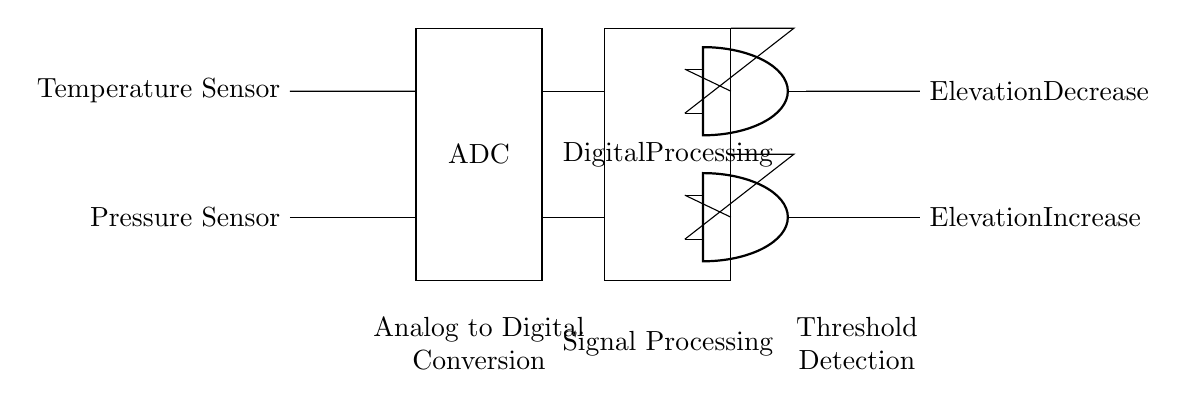What are the input sensors used in this circuit? The circuit shows a pressure sensor and a temperature sensor as inputs. These sensors gather data which will be processed to determine elevation changes.
Answer: Pressure sensor, Temperature sensor What does the ADC stand for in the circuit? In this context, ADC stands for Analog to Digital Converter. It converts the analog signals from the sensors into digital signals that can be processed.
Answer: Analog to Digital Converter How many AND gates are present in the circuit? There are two AND gates indicated in the circuit. Each AND gate has different inputs that contribute to detecting elevation changes.
Answer: Two What is the function of the second AND gate? The second AND gate processes the data for detecting elevation decrease. It takes inputs from the digital processing unit and determines if the criteria for decrease are met.
Answer: Elevation Decrease Explain the purpose of digital processing in this circuit. Digital processing is essential as it manipulates the digital data received from the ADC before being passed to the AND gates. This processing is crucial for making decisions about elevation changes.
Answer: Data manipulation Which output indicates an elevation increase? The output line that leads from the first AND gate indicates an elevation increase. This means the inputs provided satisfied the conditions for detecting an upward change in elevation.
Answer: Elevation Increase 